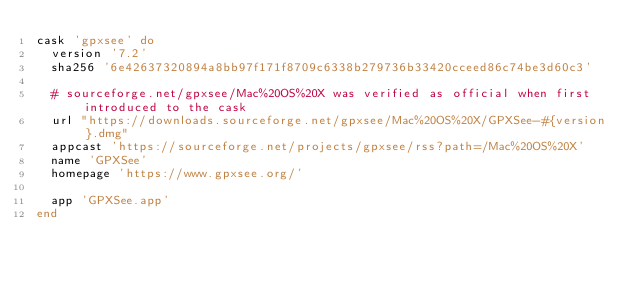<code> <loc_0><loc_0><loc_500><loc_500><_Ruby_>cask 'gpxsee' do
  version '7.2'
  sha256 '6e42637320894a8bb97f171f8709c6338b279736b33420cceed86c74be3d60c3'

  # sourceforge.net/gpxsee/Mac%20OS%20X was verified as official when first introduced to the cask
  url "https://downloads.sourceforge.net/gpxsee/Mac%20OS%20X/GPXSee-#{version}.dmg"
  appcast 'https://sourceforge.net/projects/gpxsee/rss?path=/Mac%20OS%20X'
  name 'GPXSee'
  homepage 'https://www.gpxsee.org/'

  app 'GPXSee.app'
end
</code> 